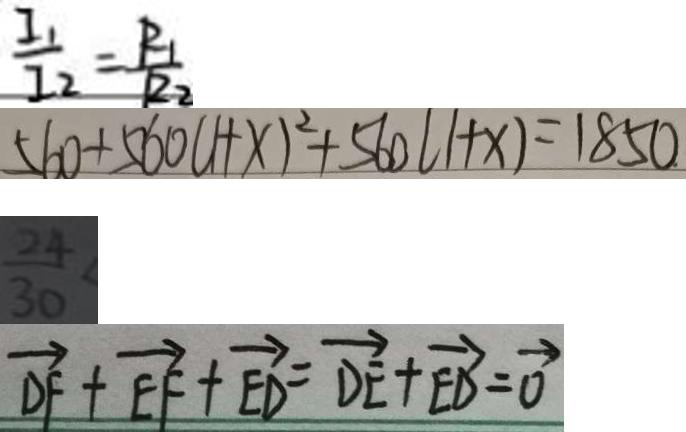Convert formula to latex. <formula><loc_0><loc_0><loc_500><loc_500>\frac { I _ { 1 } } { I _ { 2 } } = \frac { R _ { 1 } } { R _ { 2 } } 
 5 6 0 + 5 6 0 ( 1 + x ) ^ { 2 } + 5 6 0 ( 1 + x ) = 1 8 5 0 
 \frac { 2 4 } { 3 0 } < 
 \overrightarrow { D F } + \overrightarrow { E F } + \overrightarrow { E D } = \overrightarrow { D E } + \overrightarrow { E D } = \overrightarrow { 0 }</formula> 